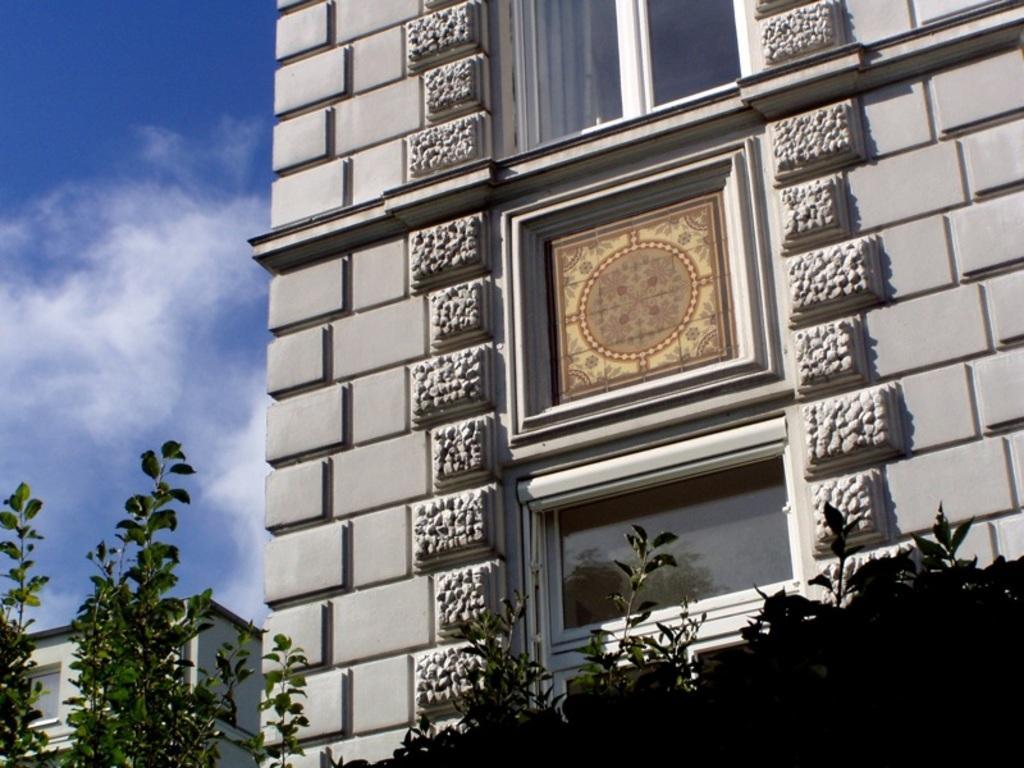Can you describe this image briefly? In this image there are plants, in the background there are buildings and the sky. 